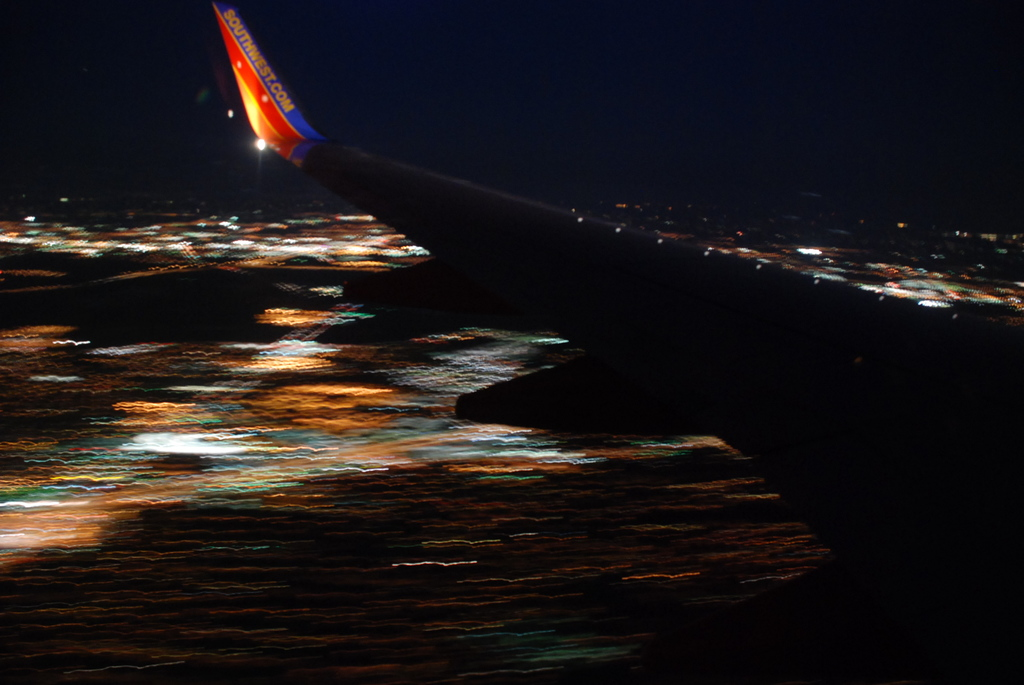How would you describe the technical aspects that led to this particular visual effect in the photograph? The blurred effect is likely due to a long exposure time used while taking the photograph from a moving aircraft; the movement of the plane relative to the bright city lights creates streaks along the direction of motion. 